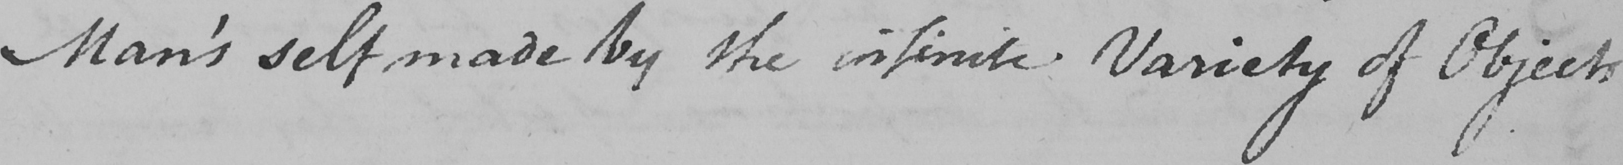What does this handwritten line say? Man ' s self made by the infinite Variety of Objects 